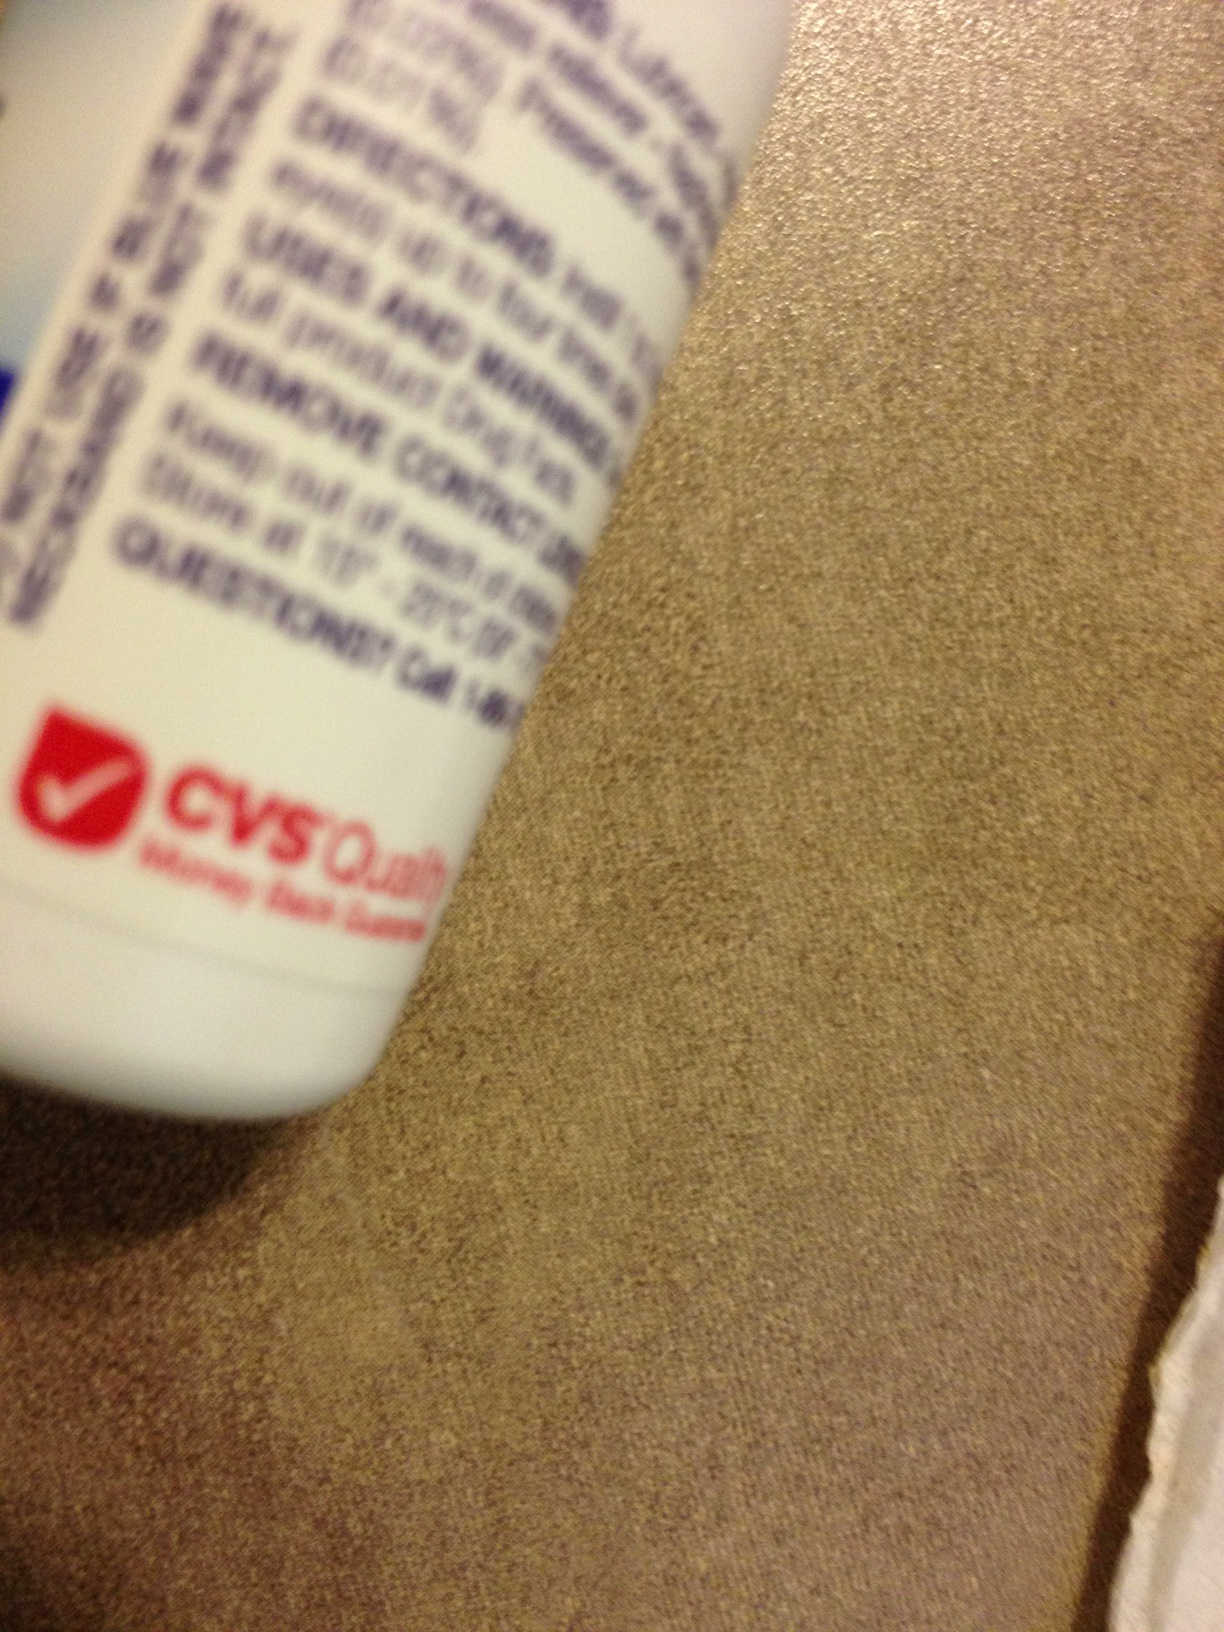What size is the bottle, and is it travel-friendly? The exact size of the bottle isn't discernible from this image alone, but based on the partial view of the bottle and its cap, it could be a smaller, possibly travel-sized bottle that may be convenient for carrying in a purse or a small bag for on-the-go use. 